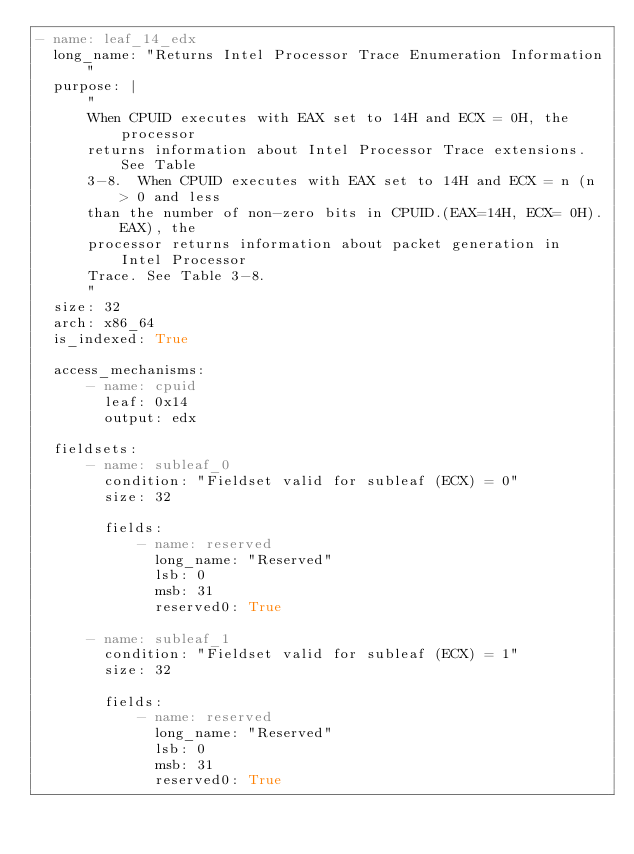<code> <loc_0><loc_0><loc_500><loc_500><_YAML_>- name: leaf_14_edx
  long_name: "Returns Intel Processor Trace Enumeration Information"
  purpose: |
      "
      When CPUID executes with EAX set to 14H and ECX = 0H, the processor
      returns information about Intel Processor Trace extensions. See Table
      3-8.  When CPUID executes with EAX set to 14H and ECX = n (n > 0 and less
      than the number of non-zero bits in CPUID.(EAX=14H, ECX= 0H).EAX), the
      processor returns information about packet generation in Intel Processor
      Trace. See Table 3-8.
      "
  size: 32
  arch: x86_64
  is_indexed: True
  
  access_mechanisms:
      - name: cpuid
        leaf: 0x14
        output: edx

  fieldsets:
      - name: subleaf_0
        condition: "Fieldset valid for subleaf (ECX) = 0"
        size: 32

        fields:
            - name: reserved
              long_name: "Reserved"
              lsb: 0
              msb: 31
              reserved0: True

      - name: subleaf_1
        condition: "Fieldset valid for subleaf (ECX) = 1"
        size: 32

        fields:
            - name: reserved
              long_name: "Reserved"
              lsb: 0
              msb: 31
              reserved0: True
</code> 